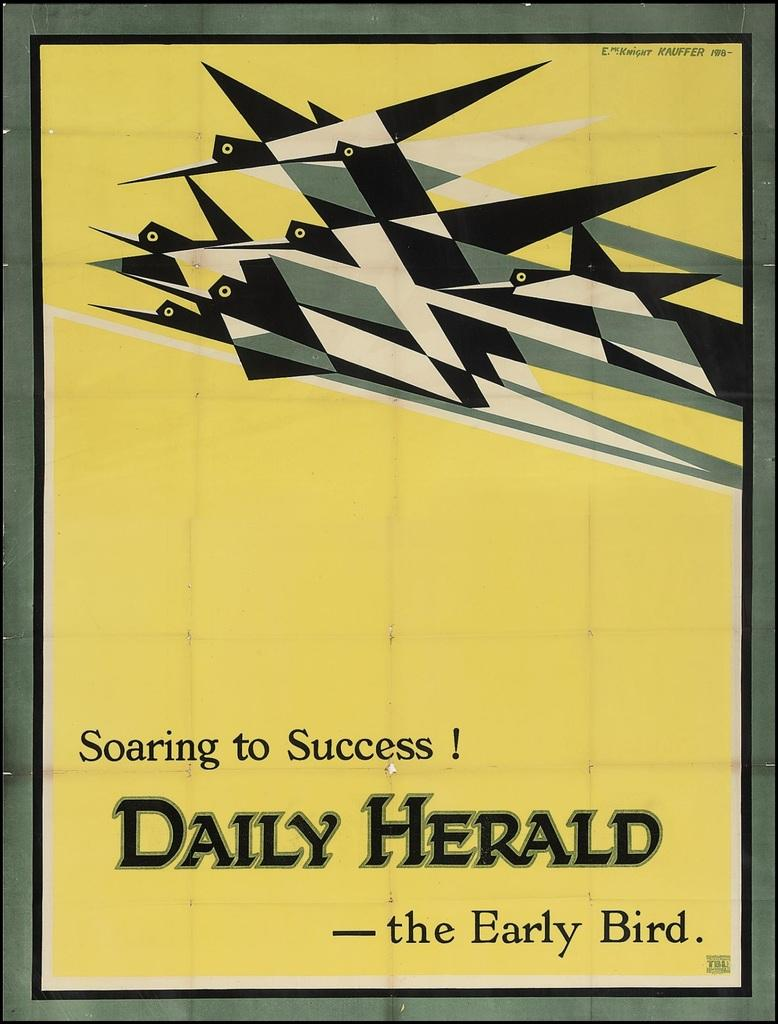<image>
Relay a brief, clear account of the picture shown. The poster shown is from the Daily Herald 